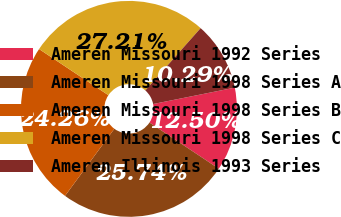Convert chart. <chart><loc_0><loc_0><loc_500><loc_500><pie_chart><fcel>Ameren Missouri 1992 Series<fcel>Ameren Missouri 1998 Series A<fcel>Ameren Missouri 1998 Series B<fcel>Ameren Missouri 1998 Series C<fcel>Ameren Illinois 1993 Series<nl><fcel>12.5%<fcel>25.74%<fcel>24.26%<fcel>27.21%<fcel>10.29%<nl></chart> 